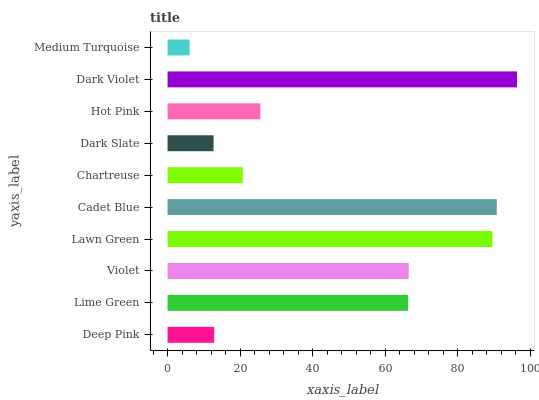Is Medium Turquoise the minimum?
Answer yes or no. Yes. Is Dark Violet the maximum?
Answer yes or no. Yes. Is Lime Green the minimum?
Answer yes or no. No. Is Lime Green the maximum?
Answer yes or no. No. Is Lime Green greater than Deep Pink?
Answer yes or no. Yes. Is Deep Pink less than Lime Green?
Answer yes or no. Yes. Is Deep Pink greater than Lime Green?
Answer yes or no. No. Is Lime Green less than Deep Pink?
Answer yes or no. No. Is Lime Green the high median?
Answer yes or no. Yes. Is Hot Pink the low median?
Answer yes or no. Yes. Is Lawn Green the high median?
Answer yes or no. No. Is Cadet Blue the low median?
Answer yes or no. No. 